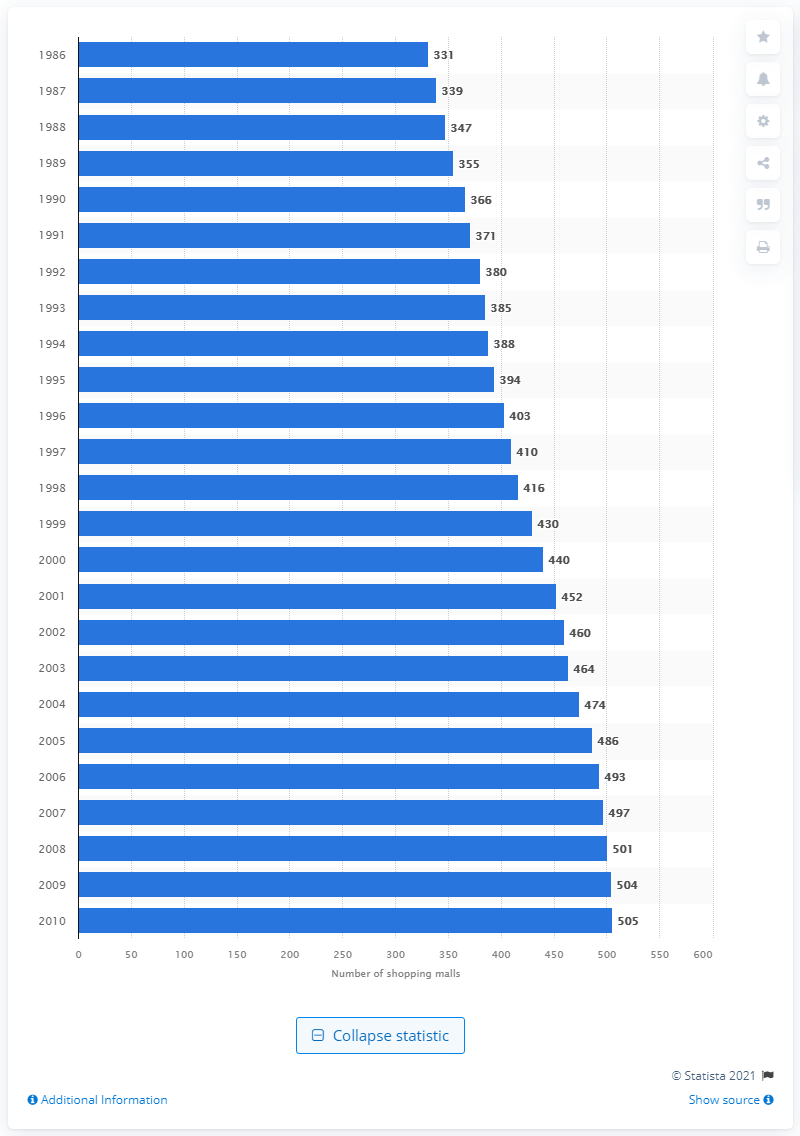Specify some key components in this picture. In 1986, there were 331 large shopping malls in the United States. 